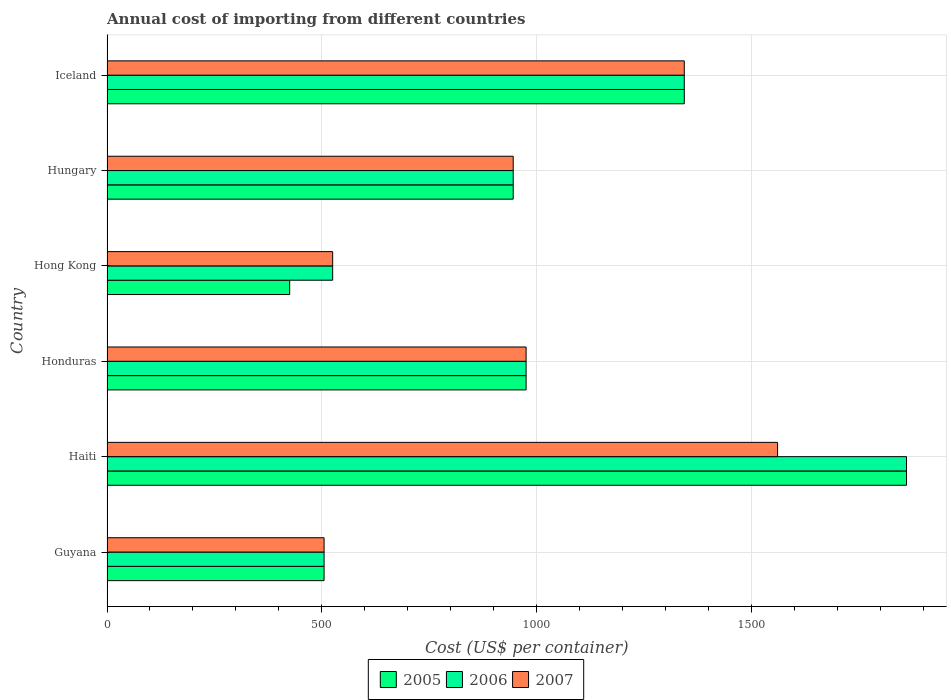How many different coloured bars are there?
Ensure brevity in your answer.  3. How many groups of bars are there?
Offer a very short reply. 6. Are the number of bars per tick equal to the number of legend labels?
Give a very brief answer. Yes. How many bars are there on the 3rd tick from the top?
Offer a very short reply. 3. How many bars are there on the 3rd tick from the bottom?
Provide a short and direct response. 3. What is the label of the 5th group of bars from the top?
Provide a succinct answer. Haiti. In how many cases, is the number of bars for a given country not equal to the number of legend labels?
Offer a terse response. 0. What is the total annual cost of importing in 2006 in Iceland?
Make the answer very short. 1343. Across all countries, what is the maximum total annual cost of importing in 2005?
Your response must be concise. 1860. Across all countries, what is the minimum total annual cost of importing in 2005?
Offer a very short reply. 425. In which country was the total annual cost of importing in 2007 maximum?
Offer a very short reply. Haiti. In which country was the total annual cost of importing in 2005 minimum?
Your response must be concise. Hong Kong. What is the total total annual cost of importing in 2007 in the graph?
Give a very brief answer. 5853. What is the difference between the total annual cost of importing in 2005 in Honduras and that in Iceland?
Your response must be concise. -368. What is the difference between the total annual cost of importing in 2006 in Hong Kong and the total annual cost of importing in 2007 in Haiti?
Keep it short and to the point. -1035. What is the average total annual cost of importing in 2006 per country?
Provide a succinct answer. 1025.5. In how many countries, is the total annual cost of importing in 2005 greater than 800 US$?
Give a very brief answer. 4. What is the ratio of the total annual cost of importing in 2005 in Haiti to that in Iceland?
Ensure brevity in your answer.  1.38. What is the difference between the highest and the second highest total annual cost of importing in 2005?
Offer a very short reply. 517. What is the difference between the highest and the lowest total annual cost of importing in 2007?
Offer a terse response. 1055. In how many countries, is the total annual cost of importing in 2005 greater than the average total annual cost of importing in 2005 taken over all countries?
Offer a very short reply. 2. What does the 1st bar from the bottom in Iceland represents?
Provide a succinct answer. 2005. How many bars are there?
Your response must be concise. 18. Are all the bars in the graph horizontal?
Give a very brief answer. Yes. Are the values on the major ticks of X-axis written in scientific E-notation?
Provide a succinct answer. No. How many legend labels are there?
Offer a very short reply. 3. How are the legend labels stacked?
Your response must be concise. Horizontal. What is the title of the graph?
Your answer should be very brief. Annual cost of importing from different countries. Does "1976" appear as one of the legend labels in the graph?
Offer a terse response. No. What is the label or title of the X-axis?
Ensure brevity in your answer.  Cost (US$ per container). What is the Cost (US$ per container) in 2005 in Guyana?
Provide a short and direct response. 505. What is the Cost (US$ per container) of 2006 in Guyana?
Your answer should be very brief. 505. What is the Cost (US$ per container) of 2007 in Guyana?
Your answer should be very brief. 505. What is the Cost (US$ per container) in 2005 in Haiti?
Offer a very short reply. 1860. What is the Cost (US$ per container) of 2006 in Haiti?
Give a very brief answer. 1860. What is the Cost (US$ per container) of 2007 in Haiti?
Provide a short and direct response. 1560. What is the Cost (US$ per container) of 2005 in Honduras?
Ensure brevity in your answer.  975. What is the Cost (US$ per container) of 2006 in Honduras?
Give a very brief answer. 975. What is the Cost (US$ per container) of 2007 in Honduras?
Your response must be concise. 975. What is the Cost (US$ per container) in 2005 in Hong Kong?
Offer a terse response. 425. What is the Cost (US$ per container) in 2006 in Hong Kong?
Offer a terse response. 525. What is the Cost (US$ per container) in 2007 in Hong Kong?
Your response must be concise. 525. What is the Cost (US$ per container) of 2005 in Hungary?
Provide a succinct answer. 945. What is the Cost (US$ per container) in 2006 in Hungary?
Provide a short and direct response. 945. What is the Cost (US$ per container) of 2007 in Hungary?
Your response must be concise. 945. What is the Cost (US$ per container) of 2005 in Iceland?
Your answer should be compact. 1343. What is the Cost (US$ per container) of 2006 in Iceland?
Offer a very short reply. 1343. What is the Cost (US$ per container) in 2007 in Iceland?
Provide a succinct answer. 1343. Across all countries, what is the maximum Cost (US$ per container) in 2005?
Offer a very short reply. 1860. Across all countries, what is the maximum Cost (US$ per container) of 2006?
Keep it short and to the point. 1860. Across all countries, what is the maximum Cost (US$ per container) of 2007?
Provide a succinct answer. 1560. Across all countries, what is the minimum Cost (US$ per container) of 2005?
Your response must be concise. 425. Across all countries, what is the minimum Cost (US$ per container) in 2006?
Your answer should be very brief. 505. Across all countries, what is the minimum Cost (US$ per container) of 2007?
Keep it short and to the point. 505. What is the total Cost (US$ per container) of 2005 in the graph?
Provide a succinct answer. 6053. What is the total Cost (US$ per container) of 2006 in the graph?
Keep it short and to the point. 6153. What is the total Cost (US$ per container) in 2007 in the graph?
Your answer should be compact. 5853. What is the difference between the Cost (US$ per container) of 2005 in Guyana and that in Haiti?
Offer a terse response. -1355. What is the difference between the Cost (US$ per container) in 2006 in Guyana and that in Haiti?
Keep it short and to the point. -1355. What is the difference between the Cost (US$ per container) of 2007 in Guyana and that in Haiti?
Ensure brevity in your answer.  -1055. What is the difference between the Cost (US$ per container) in 2005 in Guyana and that in Honduras?
Offer a terse response. -470. What is the difference between the Cost (US$ per container) in 2006 in Guyana and that in Honduras?
Your answer should be compact. -470. What is the difference between the Cost (US$ per container) in 2007 in Guyana and that in Honduras?
Provide a short and direct response. -470. What is the difference between the Cost (US$ per container) in 2005 in Guyana and that in Hong Kong?
Make the answer very short. 80. What is the difference between the Cost (US$ per container) in 2005 in Guyana and that in Hungary?
Your response must be concise. -440. What is the difference between the Cost (US$ per container) in 2006 in Guyana and that in Hungary?
Provide a succinct answer. -440. What is the difference between the Cost (US$ per container) in 2007 in Guyana and that in Hungary?
Offer a very short reply. -440. What is the difference between the Cost (US$ per container) of 2005 in Guyana and that in Iceland?
Provide a short and direct response. -838. What is the difference between the Cost (US$ per container) of 2006 in Guyana and that in Iceland?
Provide a short and direct response. -838. What is the difference between the Cost (US$ per container) in 2007 in Guyana and that in Iceland?
Offer a very short reply. -838. What is the difference between the Cost (US$ per container) in 2005 in Haiti and that in Honduras?
Ensure brevity in your answer.  885. What is the difference between the Cost (US$ per container) in 2006 in Haiti and that in Honduras?
Ensure brevity in your answer.  885. What is the difference between the Cost (US$ per container) in 2007 in Haiti and that in Honduras?
Ensure brevity in your answer.  585. What is the difference between the Cost (US$ per container) in 2005 in Haiti and that in Hong Kong?
Your response must be concise. 1435. What is the difference between the Cost (US$ per container) in 2006 in Haiti and that in Hong Kong?
Provide a succinct answer. 1335. What is the difference between the Cost (US$ per container) of 2007 in Haiti and that in Hong Kong?
Give a very brief answer. 1035. What is the difference between the Cost (US$ per container) in 2005 in Haiti and that in Hungary?
Ensure brevity in your answer.  915. What is the difference between the Cost (US$ per container) in 2006 in Haiti and that in Hungary?
Offer a very short reply. 915. What is the difference between the Cost (US$ per container) in 2007 in Haiti and that in Hungary?
Offer a terse response. 615. What is the difference between the Cost (US$ per container) in 2005 in Haiti and that in Iceland?
Give a very brief answer. 517. What is the difference between the Cost (US$ per container) in 2006 in Haiti and that in Iceland?
Provide a succinct answer. 517. What is the difference between the Cost (US$ per container) in 2007 in Haiti and that in Iceland?
Keep it short and to the point. 217. What is the difference between the Cost (US$ per container) in 2005 in Honduras and that in Hong Kong?
Your answer should be very brief. 550. What is the difference between the Cost (US$ per container) of 2006 in Honduras and that in Hong Kong?
Offer a terse response. 450. What is the difference between the Cost (US$ per container) in 2007 in Honduras and that in Hong Kong?
Offer a terse response. 450. What is the difference between the Cost (US$ per container) of 2005 in Honduras and that in Iceland?
Provide a succinct answer. -368. What is the difference between the Cost (US$ per container) in 2006 in Honduras and that in Iceland?
Offer a terse response. -368. What is the difference between the Cost (US$ per container) of 2007 in Honduras and that in Iceland?
Give a very brief answer. -368. What is the difference between the Cost (US$ per container) in 2005 in Hong Kong and that in Hungary?
Your answer should be very brief. -520. What is the difference between the Cost (US$ per container) in 2006 in Hong Kong and that in Hungary?
Keep it short and to the point. -420. What is the difference between the Cost (US$ per container) in 2007 in Hong Kong and that in Hungary?
Ensure brevity in your answer.  -420. What is the difference between the Cost (US$ per container) of 2005 in Hong Kong and that in Iceland?
Ensure brevity in your answer.  -918. What is the difference between the Cost (US$ per container) in 2006 in Hong Kong and that in Iceland?
Provide a succinct answer. -818. What is the difference between the Cost (US$ per container) in 2007 in Hong Kong and that in Iceland?
Your response must be concise. -818. What is the difference between the Cost (US$ per container) in 2005 in Hungary and that in Iceland?
Provide a short and direct response. -398. What is the difference between the Cost (US$ per container) of 2006 in Hungary and that in Iceland?
Your answer should be very brief. -398. What is the difference between the Cost (US$ per container) in 2007 in Hungary and that in Iceland?
Ensure brevity in your answer.  -398. What is the difference between the Cost (US$ per container) in 2005 in Guyana and the Cost (US$ per container) in 2006 in Haiti?
Offer a very short reply. -1355. What is the difference between the Cost (US$ per container) in 2005 in Guyana and the Cost (US$ per container) in 2007 in Haiti?
Give a very brief answer. -1055. What is the difference between the Cost (US$ per container) of 2006 in Guyana and the Cost (US$ per container) of 2007 in Haiti?
Provide a short and direct response. -1055. What is the difference between the Cost (US$ per container) of 2005 in Guyana and the Cost (US$ per container) of 2006 in Honduras?
Give a very brief answer. -470. What is the difference between the Cost (US$ per container) in 2005 in Guyana and the Cost (US$ per container) in 2007 in Honduras?
Provide a succinct answer. -470. What is the difference between the Cost (US$ per container) in 2006 in Guyana and the Cost (US$ per container) in 2007 in Honduras?
Your answer should be compact. -470. What is the difference between the Cost (US$ per container) in 2005 in Guyana and the Cost (US$ per container) in 2006 in Hong Kong?
Your answer should be compact. -20. What is the difference between the Cost (US$ per container) in 2005 in Guyana and the Cost (US$ per container) in 2007 in Hong Kong?
Ensure brevity in your answer.  -20. What is the difference between the Cost (US$ per container) of 2005 in Guyana and the Cost (US$ per container) of 2006 in Hungary?
Make the answer very short. -440. What is the difference between the Cost (US$ per container) of 2005 in Guyana and the Cost (US$ per container) of 2007 in Hungary?
Make the answer very short. -440. What is the difference between the Cost (US$ per container) in 2006 in Guyana and the Cost (US$ per container) in 2007 in Hungary?
Offer a terse response. -440. What is the difference between the Cost (US$ per container) of 2005 in Guyana and the Cost (US$ per container) of 2006 in Iceland?
Keep it short and to the point. -838. What is the difference between the Cost (US$ per container) in 2005 in Guyana and the Cost (US$ per container) in 2007 in Iceland?
Ensure brevity in your answer.  -838. What is the difference between the Cost (US$ per container) in 2006 in Guyana and the Cost (US$ per container) in 2007 in Iceland?
Your answer should be compact. -838. What is the difference between the Cost (US$ per container) in 2005 in Haiti and the Cost (US$ per container) in 2006 in Honduras?
Provide a short and direct response. 885. What is the difference between the Cost (US$ per container) of 2005 in Haiti and the Cost (US$ per container) of 2007 in Honduras?
Ensure brevity in your answer.  885. What is the difference between the Cost (US$ per container) in 2006 in Haiti and the Cost (US$ per container) in 2007 in Honduras?
Your answer should be compact. 885. What is the difference between the Cost (US$ per container) in 2005 in Haiti and the Cost (US$ per container) in 2006 in Hong Kong?
Ensure brevity in your answer.  1335. What is the difference between the Cost (US$ per container) of 2005 in Haiti and the Cost (US$ per container) of 2007 in Hong Kong?
Your answer should be very brief. 1335. What is the difference between the Cost (US$ per container) of 2006 in Haiti and the Cost (US$ per container) of 2007 in Hong Kong?
Your response must be concise. 1335. What is the difference between the Cost (US$ per container) in 2005 in Haiti and the Cost (US$ per container) in 2006 in Hungary?
Provide a succinct answer. 915. What is the difference between the Cost (US$ per container) in 2005 in Haiti and the Cost (US$ per container) in 2007 in Hungary?
Offer a terse response. 915. What is the difference between the Cost (US$ per container) in 2006 in Haiti and the Cost (US$ per container) in 2007 in Hungary?
Provide a short and direct response. 915. What is the difference between the Cost (US$ per container) in 2005 in Haiti and the Cost (US$ per container) in 2006 in Iceland?
Your answer should be very brief. 517. What is the difference between the Cost (US$ per container) in 2005 in Haiti and the Cost (US$ per container) in 2007 in Iceland?
Ensure brevity in your answer.  517. What is the difference between the Cost (US$ per container) in 2006 in Haiti and the Cost (US$ per container) in 2007 in Iceland?
Make the answer very short. 517. What is the difference between the Cost (US$ per container) of 2005 in Honduras and the Cost (US$ per container) of 2006 in Hong Kong?
Offer a very short reply. 450. What is the difference between the Cost (US$ per container) of 2005 in Honduras and the Cost (US$ per container) of 2007 in Hong Kong?
Ensure brevity in your answer.  450. What is the difference between the Cost (US$ per container) of 2006 in Honduras and the Cost (US$ per container) of 2007 in Hong Kong?
Ensure brevity in your answer.  450. What is the difference between the Cost (US$ per container) of 2005 in Honduras and the Cost (US$ per container) of 2006 in Hungary?
Provide a succinct answer. 30. What is the difference between the Cost (US$ per container) of 2005 in Honduras and the Cost (US$ per container) of 2007 in Hungary?
Keep it short and to the point. 30. What is the difference between the Cost (US$ per container) of 2005 in Honduras and the Cost (US$ per container) of 2006 in Iceland?
Offer a terse response. -368. What is the difference between the Cost (US$ per container) in 2005 in Honduras and the Cost (US$ per container) in 2007 in Iceland?
Offer a very short reply. -368. What is the difference between the Cost (US$ per container) in 2006 in Honduras and the Cost (US$ per container) in 2007 in Iceland?
Provide a short and direct response. -368. What is the difference between the Cost (US$ per container) in 2005 in Hong Kong and the Cost (US$ per container) in 2006 in Hungary?
Provide a succinct answer. -520. What is the difference between the Cost (US$ per container) in 2005 in Hong Kong and the Cost (US$ per container) in 2007 in Hungary?
Offer a terse response. -520. What is the difference between the Cost (US$ per container) of 2006 in Hong Kong and the Cost (US$ per container) of 2007 in Hungary?
Your response must be concise. -420. What is the difference between the Cost (US$ per container) in 2005 in Hong Kong and the Cost (US$ per container) in 2006 in Iceland?
Your answer should be compact. -918. What is the difference between the Cost (US$ per container) of 2005 in Hong Kong and the Cost (US$ per container) of 2007 in Iceland?
Provide a short and direct response. -918. What is the difference between the Cost (US$ per container) in 2006 in Hong Kong and the Cost (US$ per container) in 2007 in Iceland?
Provide a short and direct response. -818. What is the difference between the Cost (US$ per container) of 2005 in Hungary and the Cost (US$ per container) of 2006 in Iceland?
Your response must be concise. -398. What is the difference between the Cost (US$ per container) in 2005 in Hungary and the Cost (US$ per container) in 2007 in Iceland?
Offer a terse response. -398. What is the difference between the Cost (US$ per container) of 2006 in Hungary and the Cost (US$ per container) of 2007 in Iceland?
Ensure brevity in your answer.  -398. What is the average Cost (US$ per container) of 2005 per country?
Your response must be concise. 1008.83. What is the average Cost (US$ per container) of 2006 per country?
Provide a succinct answer. 1025.5. What is the average Cost (US$ per container) of 2007 per country?
Offer a very short reply. 975.5. What is the difference between the Cost (US$ per container) in 2005 and Cost (US$ per container) in 2006 in Guyana?
Make the answer very short. 0. What is the difference between the Cost (US$ per container) in 2005 and Cost (US$ per container) in 2007 in Guyana?
Offer a terse response. 0. What is the difference between the Cost (US$ per container) of 2005 and Cost (US$ per container) of 2007 in Haiti?
Provide a short and direct response. 300. What is the difference between the Cost (US$ per container) of 2006 and Cost (US$ per container) of 2007 in Haiti?
Provide a short and direct response. 300. What is the difference between the Cost (US$ per container) of 2005 and Cost (US$ per container) of 2006 in Honduras?
Provide a short and direct response. 0. What is the difference between the Cost (US$ per container) in 2005 and Cost (US$ per container) in 2006 in Hong Kong?
Your answer should be compact. -100. What is the difference between the Cost (US$ per container) of 2005 and Cost (US$ per container) of 2007 in Hong Kong?
Keep it short and to the point. -100. What is the difference between the Cost (US$ per container) in 2005 and Cost (US$ per container) in 2006 in Hungary?
Your response must be concise. 0. What is the difference between the Cost (US$ per container) in 2005 and Cost (US$ per container) in 2007 in Hungary?
Give a very brief answer. 0. What is the difference between the Cost (US$ per container) of 2005 and Cost (US$ per container) of 2006 in Iceland?
Make the answer very short. 0. What is the difference between the Cost (US$ per container) of 2006 and Cost (US$ per container) of 2007 in Iceland?
Keep it short and to the point. 0. What is the ratio of the Cost (US$ per container) in 2005 in Guyana to that in Haiti?
Ensure brevity in your answer.  0.27. What is the ratio of the Cost (US$ per container) of 2006 in Guyana to that in Haiti?
Ensure brevity in your answer.  0.27. What is the ratio of the Cost (US$ per container) of 2007 in Guyana to that in Haiti?
Your answer should be compact. 0.32. What is the ratio of the Cost (US$ per container) of 2005 in Guyana to that in Honduras?
Your answer should be very brief. 0.52. What is the ratio of the Cost (US$ per container) in 2006 in Guyana to that in Honduras?
Give a very brief answer. 0.52. What is the ratio of the Cost (US$ per container) in 2007 in Guyana to that in Honduras?
Keep it short and to the point. 0.52. What is the ratio of the Cost (US$ per container) in 2005 in Guyana to that in Hong Kong?
Give a very brief answer. 1.19. What is the ratio of the Cost (US$ per container) of 2006 in Guyana to that in Hong Kong?
Provide a short and direct response. 0.96. What is the ratio of the Cost (US$ per container) in 2007 in Guyana to that in Hong Kong?
Your answer should be very brief. 0.96. What is the ratio of the Cost (US$ per container) of 2005 in Guyana to that in Hungary?
Provide a short and direct response. 0.53. What is the ratio of the Cost (US$ per container) in 2006 in Guyana to that in Hungary?
Offer a very short reply. 0.53. What is the ratio of the Cost (US$ per container) of 2007 in Guyana to that in Hungary?
Make the answer very short. 0.53. What is the ratio of the Cost (US$ per container) in 2005 in Guyana to that in Iceland?
Provide a succinct answer. 0.38. What is the ratio of the Cost (US$ per container) of 2006 in Guyana to that in Iceland?
Your response must be concise. 0.38. What is the ratio of the Cost (US$ per container) of 2007 in Guyana to that in Iceland?
Offer a very short reply. 0.38. What is the ratio of the Cost (US$ per container) of 2005 in Haiti to that in Honduras?
Offer a very short reply. 1.91. What is the ratio of the Cost (US$ per container) in 2006 in Haiti to that in Honduras?
Your answer should be compact. 1.91. What is the ratio of the Cost (US$ per container) in 2005 in Haiti to that in Hong Kong?
Provide a short and direct response. 4.38. What is the ratio of the Cost (US$ per container) of 2006 in Haiti to that in Hong Kong?
Your response must be concise. 3.54. What is the ratio of the Cost (US$ per container) in 2007 in Haiti to that in Hong Kong?
Make the answer very short. 2.97. What is the ratio of the Cost (US$ per container) of 2005 in Haiti to that in Hungary?
Your response must be concise. 1.97. What is the ratio of the Cost (US$ per container) of 2006 in Haiti to that in Hungary?
Offer a very short reply. 1.97. What is the ratio of the Cost (US$ per container) in 2007 in Haiti to that in Hungary?
Your response must be concise. 1.65. What is the ratio of the Cost (US$ per container) in 2005 in Haiti to that in Iceland?
Ensure brevity in your answer.  1.39. What is the ratio of the Cost (US$ per container) in 2006 in Haiti to that in Iceland?
Offer a very short reply. 1.39. What is the ratio of the Cost (US$ per container) in 2007 in Haiti to that in Iceland?
Offer a terse response. 1.16. What is the ratio of the Cost (US$ per container) in 2005 in Honduras to that in Hong Kong?
Offer a terse response. 2.29. What is the ratio of the Cost (US$ per container) in 2006 in Honduras to that in Hong Kong?
Keep it short and to the point. 1.86. What is the ratio of the Cost (US$ per container) of 2007 in Honduras to that in Hong Kong?
Your answer should be very brief. 1.86. What is the ratio of the Cost (US$ per container) of 2005 in Honduras to that in Hungary?
Give a very brief answer. 1.03. What is the ratio of the Cost (US$ per container) of 2006 in Honduras to that in Hungary?
Keep it short and to the point. 1.03. What is the ratio of the Cost (US$ per container) of 2007 in Honduras to that in Hungary?
Keep it short and to the point. 1.03. What is the ratio of the Cost (US$ per container) in 2005 in Honduras to that in Iceland?
Ensure brevity in your answer.  0.73. What is the ratio of the Cost (US$ per container) in 2006 in Honduras to that in Iceland?
Provide a short and direct response. 0.73. What is the ratio of the Cost (US$ per container) of 2007 in Honduras to that in Iceland?
Your response must be concise. 0.73. What is the ratio of the Cost (US$ per container) of 2005 in Hong Kong to that in Hungary?
Provide a short and direct response. 0.45. What is the ratio of the Cost (US$ per container) of 2006 in Hong Kong to that in Hungary?
Keep it short and to the point. 0.56. What is the ratio of the Cost (US$ per container) of 2007 in Hong Kong to that in Hungary?
Offer a terse response. 0.56. What is the ratio of the Cost (US$ per container) in 2005 in Hong Kong to that in Iceland?
Ensure brevity in your answer.  0.32. What is the ratio of the Cost (US$ per container) in 2006 in Hong Kong to that in Iceland?
Offer a terse response. 0.39. What is the ratio of the Cost (US$ per container) of 2007 in Hong Kong to that in Iceland?
Your response must be concise. 0.39. What is the ratio of the Cost (US$ per container) in 2005 in Hungary to that in Iceland?
Give a very brief answer. 0.7. What is the ratio of the Cost (US$ per container) in 2006 in Hungary to that in Iceland?
Provide a succinct answer. 0.7. What is the ratio of the Cost (US$ per container) of 2007 in Hungary to that in Iceland?
Your answer should be compact. 0.7. What is the difference between the highest and the second highest Cost (US$ per container) of 2005?
Keep it short and to the point. 517. What is the difference between the highest and the second highest Cost (US$ per container) of 2006?
Give a very brief answer. 517. What is the difference between the highest and the second highest Cost (US$ per container) in 2007?
Your answer should be compact. 217. What is the difference between the highest and the lowest Cost (US$ per container) in 2005?
Give a very brief answer. 1435. What is the difference between the highest and the lowest Cost (US$ per container) in 2006?
Keep it short and to the point. 1355. What is the difference between the highest and the lowest Cost (US$ per container) in 2007?
Keep it short and to the point. 1055. 